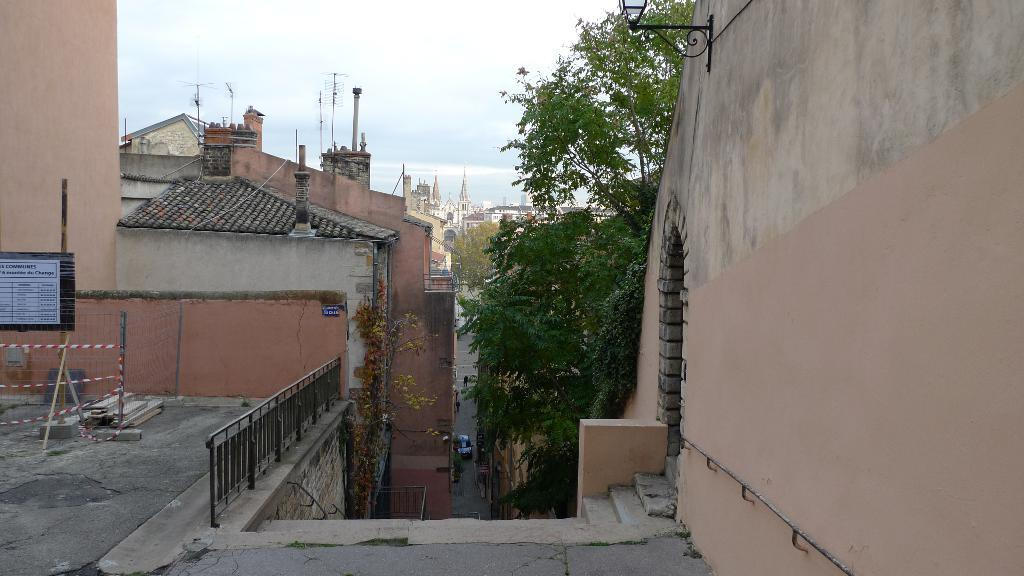What structures are located in the middle of the image? There are buildings and a tree in the middle of the image. What is visible at the top of the image? The sky is visible at the top of the image. What type of vehicle can be seen at the bottom of the image? There is a car at the bottom of the image. What type of advertisement can be seen on the tree in the image? There is no advertisement present on the tree in the image; it is a tree with no additional features mentioned. 